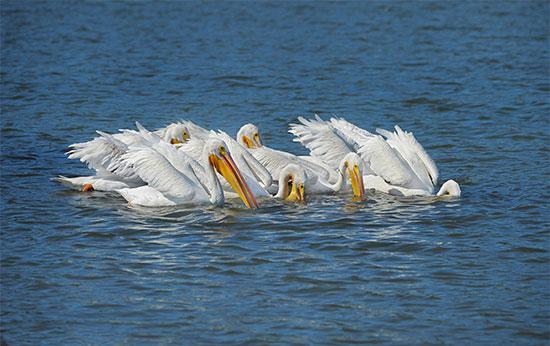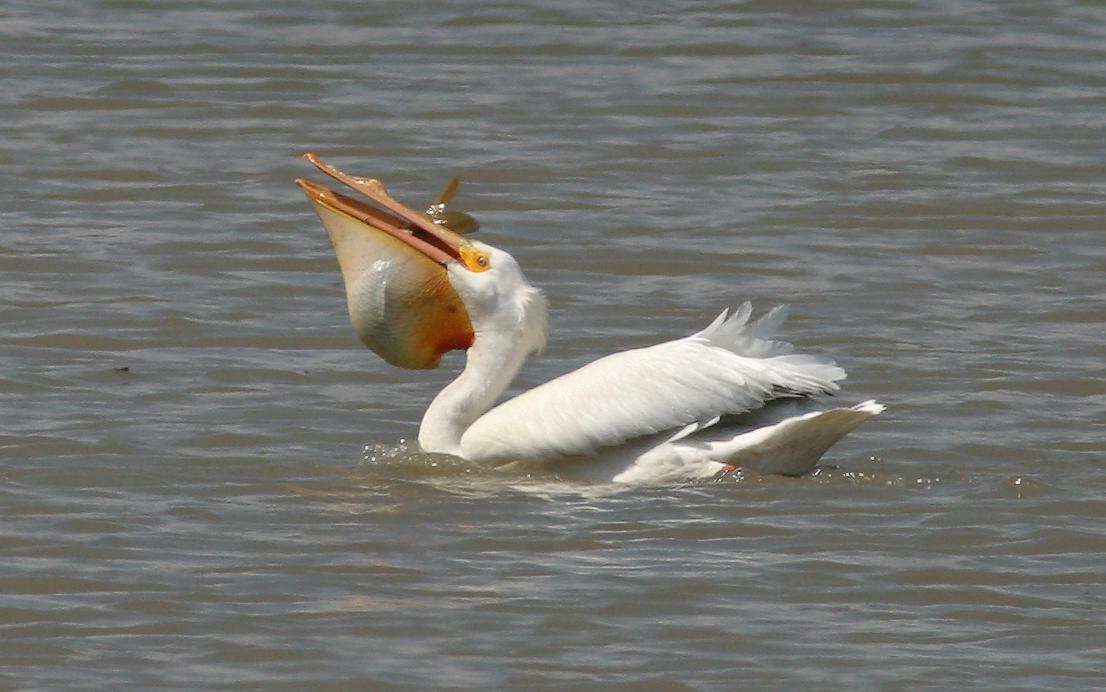The first image is the image on the left, the second image is the image on the right. Analyze the images presented: Is the assertion "There are two pelicans flying" valid? Answer yes or no. No. 